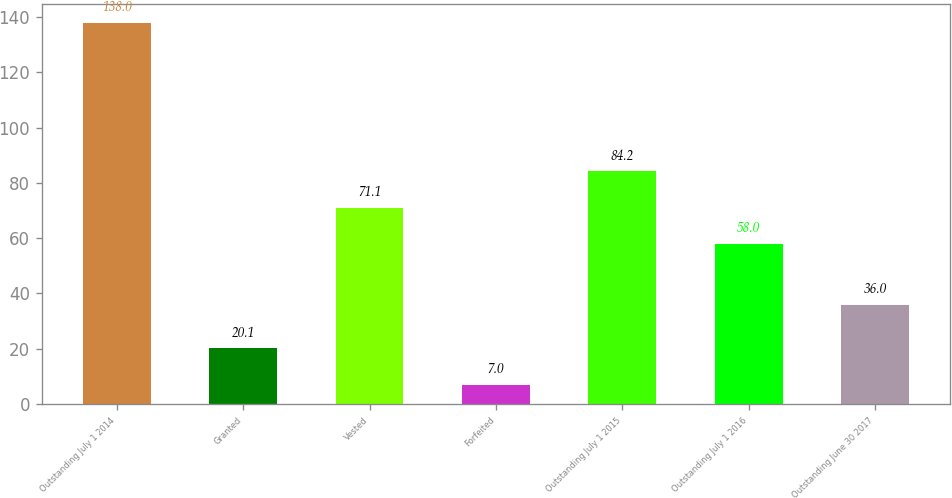Convert chart. <chart><loc_0><loc_0><loc_500><loc_500><bar_chart><fcel>Outstanding July 1 2014<fcel>Granted<fcel>Vested<fcel>Forfeited<fcel>Outstanding July 1 2015<fcel>Outstanding July 1 2016<fcel>Outstanding June 30 2017<nl><fcel>138<fcel>20.1<fcel>71.1<fcel>7<fcel>84.2<fcel>58<fcel>36<nl></chart> 